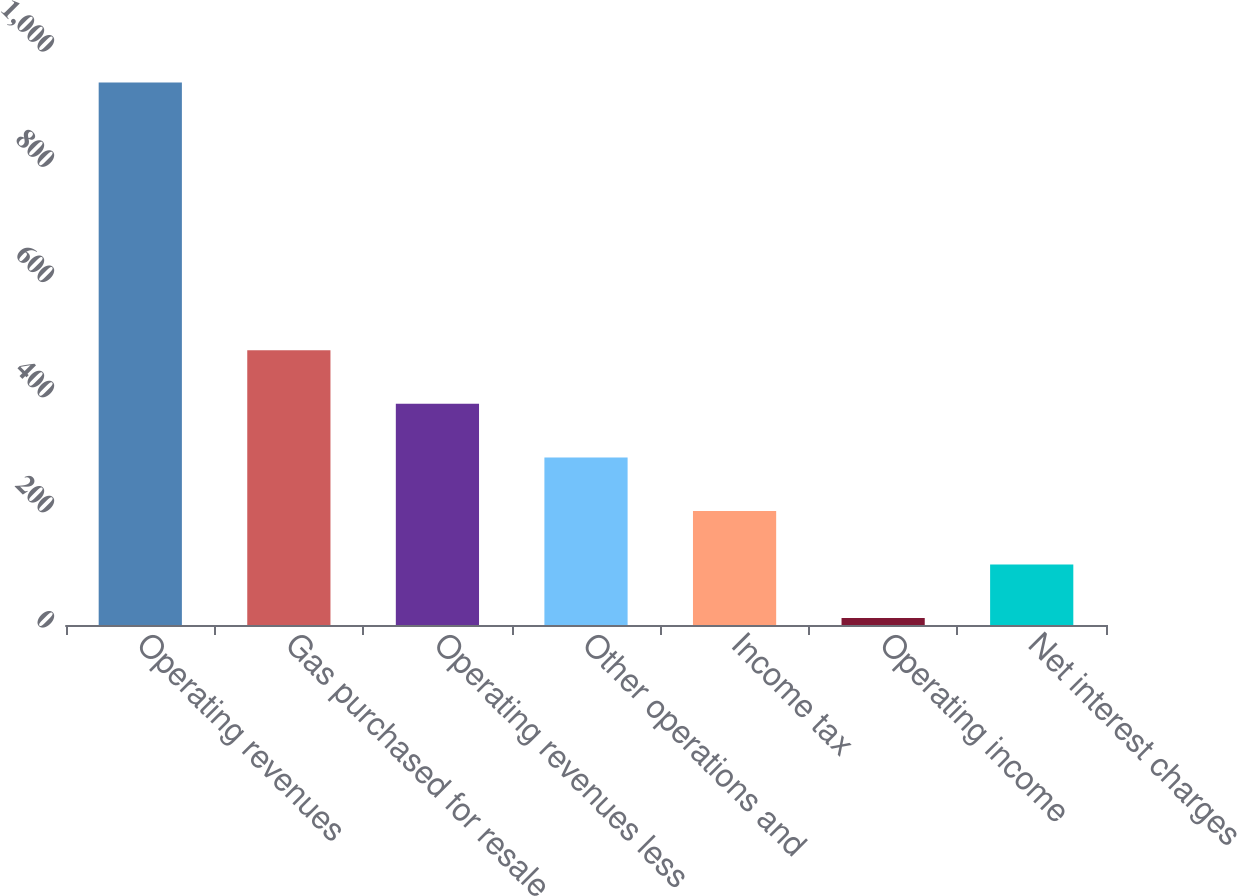Convert chart to OTSL. <chart><loc_0><loc_0><loc_500><loc_500><bar_chart><fcel>Operating revenues<fcel>Gas purchased for resale<fcel>Operating revenues less<fcel>Other operations and<fcel>Income tax<fcel>Operating income<fcel>Net interest charges<nl><fcel>942<fcel>477<fcel>384<fcel>291<fcel>198<fcel>12<fcel>105<nl></chart> 